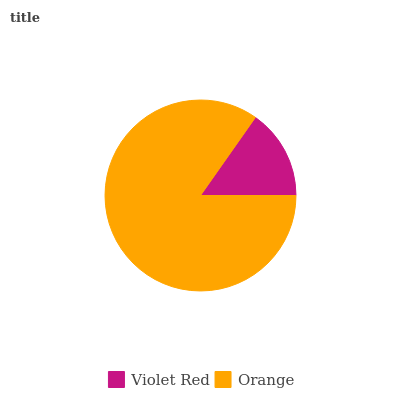Is Violet Red the minimum?
Answer yes or no. Yes. Is Orange the maximum?
Answer yes or no. Yes. Is Orange the minimum?
Answer yes or no. No. Is Orange greater than Violet Red?
Answer yes or no. Yes. Is Violet Red less than Orange?
Answer yes or no. Yes. Is Violet Red greater than Orange?
Answer yes or no. No. Is Orange less than Violet Red?
Answer yes or no. No. Is Orange the high median?
Answer yes or no. Yes. Is Violet Red the low median?
Answer yes or no. Yes. Is Violet Red the high median?
Answer yes or no. No. Is Orange the low median?
Answer yes or no. No. 